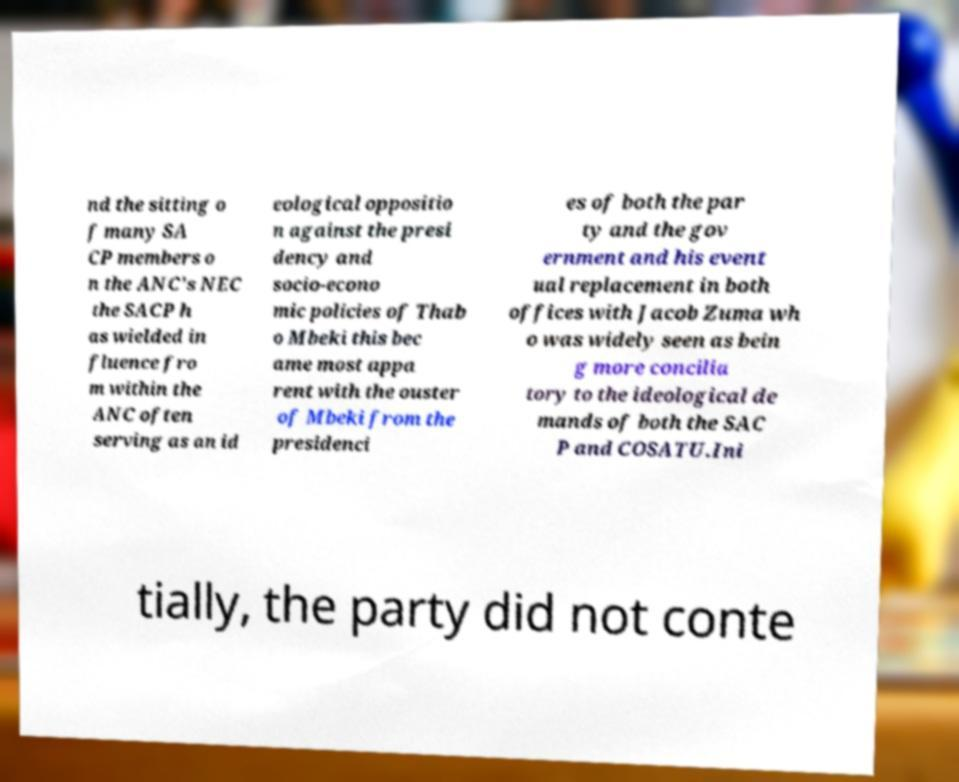Please identify and transcribe the text found in this image. nd the sitting o f many SA CP members o n the ANC's NEC the SACP h as wielded in fluence fro m within the ANC often serving as an id eological oppositio n against the presi dency and socio-econo mic policies of Thab o Mbeki this bec ame most appa rent with the ouster of Mbeki from the presidenci es of both the par ty and the gov ernment and his event ual replacement in both offices with Jacob Zuma wh o was widely seen as bein g more concilia tory to the ideological de mands of both the SAC P and COSATU.Ini tially, the party did not conte 